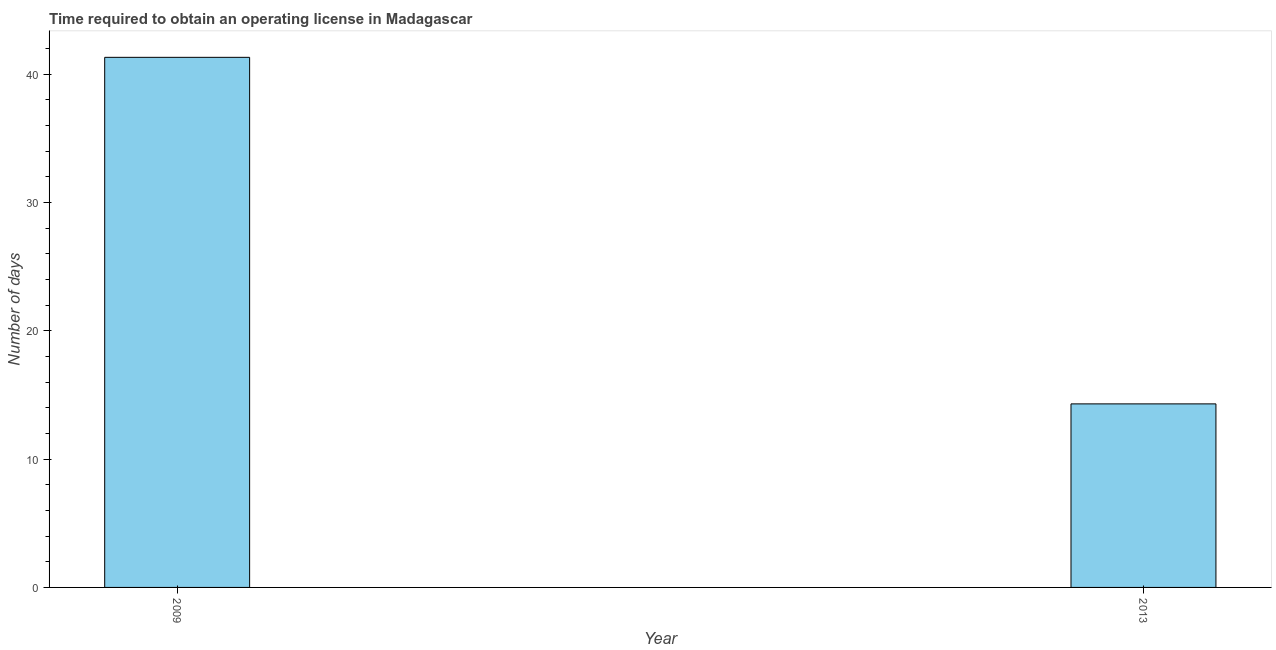What is the title of the graph?
Give a very brief answer. Time required to obtain an operating license in Madagascar. What is the label or title of the Y-axis?
Your answer should be very brief. Number of days. Across all years, what is the maximum number of days to obtain operating license?
Provide a short and direct response. 41.3. In which year was the number of days to obtain operating license minimum?
Your answer should be compact. 2013. What is the sum of the number of days to obtain operating license?
Provide a succinct answer. 55.6. What is the average number of days to obtain operating license per year?
Provide a short and direct response. 27.8. What is the median number of days to obtain operating license?
Provide a short and direct response. 27.8. In how many years, is the number of days to obtain operating license greater than 14 days?
Offer a very short reply. 2. What is the ratio of the number of days to obtain operating license in 2009 to that in 2013?
Provide a succinct answer. 2.89. In how many years, is the number of days to obtain operating license greater than the average number of days to obtain operating license taken over all years?
Provide a succinct answer. 1. How many bars are there?
Your answer should be compact. 2. How many years are there in the graph?
Offer a very short reply. 2. What is the difference between two consecutive major ticks on the Y-axis?
Your answer should be very brief. 10. What is the Number of days in 2009?
Ensure brevity in your answer.  41.3. What is the Number of days of 2013?
Keep it short and to the point. 14.3. What is the difference between the Number of days in 2009 and 2013?
Provide a succinct answer. 27. What is the ratio of the Number of days in 2009 to that in 2013?
Keep it short and to the point. 2.89. 